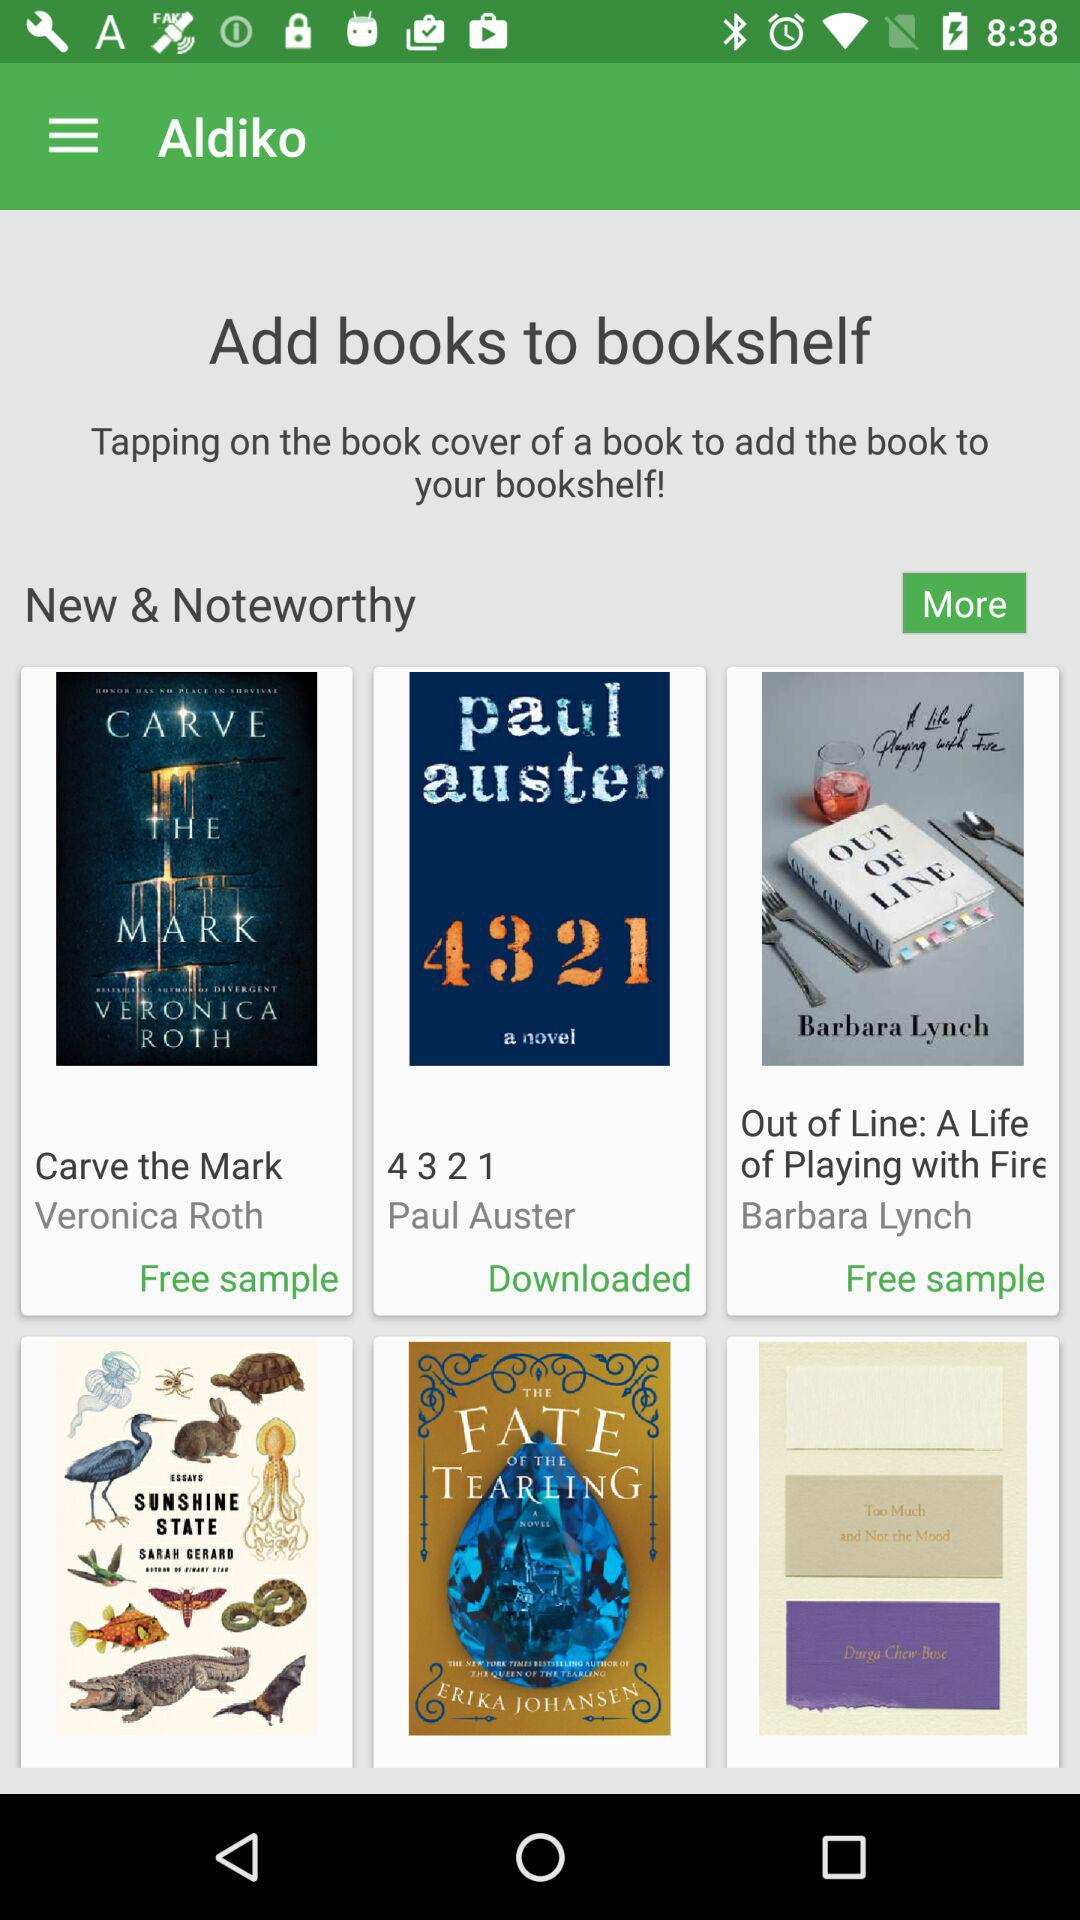How many books are not downloaded?
Answer the question using a single word or phrase. 2 